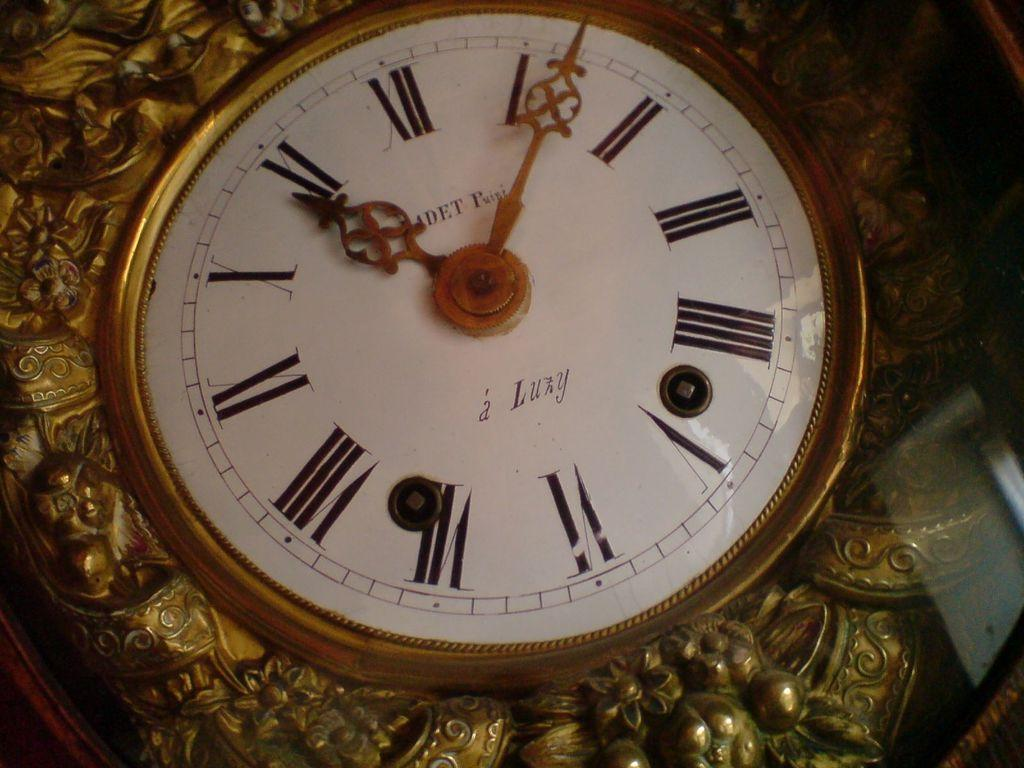<image>
Create a compact narrative representing the image presented. Face of a watch which says Luxy on it. 